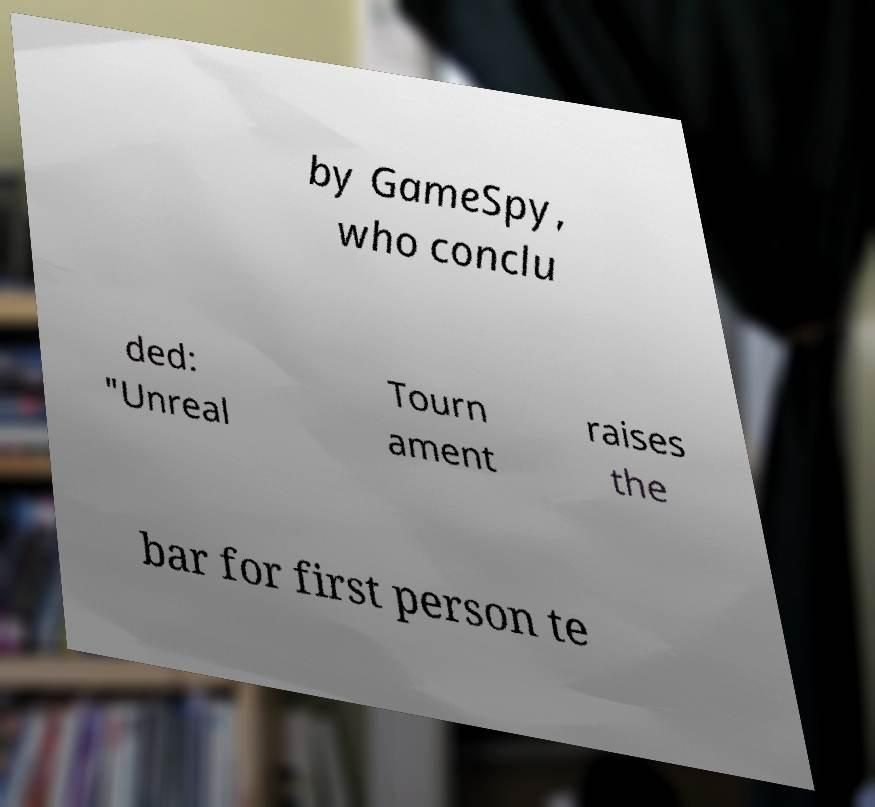I need the written content from this picture converted into text. Can you do that? by GameSpy, who conclu ded: "Unreal Tourn ament raises the bar for first person te 